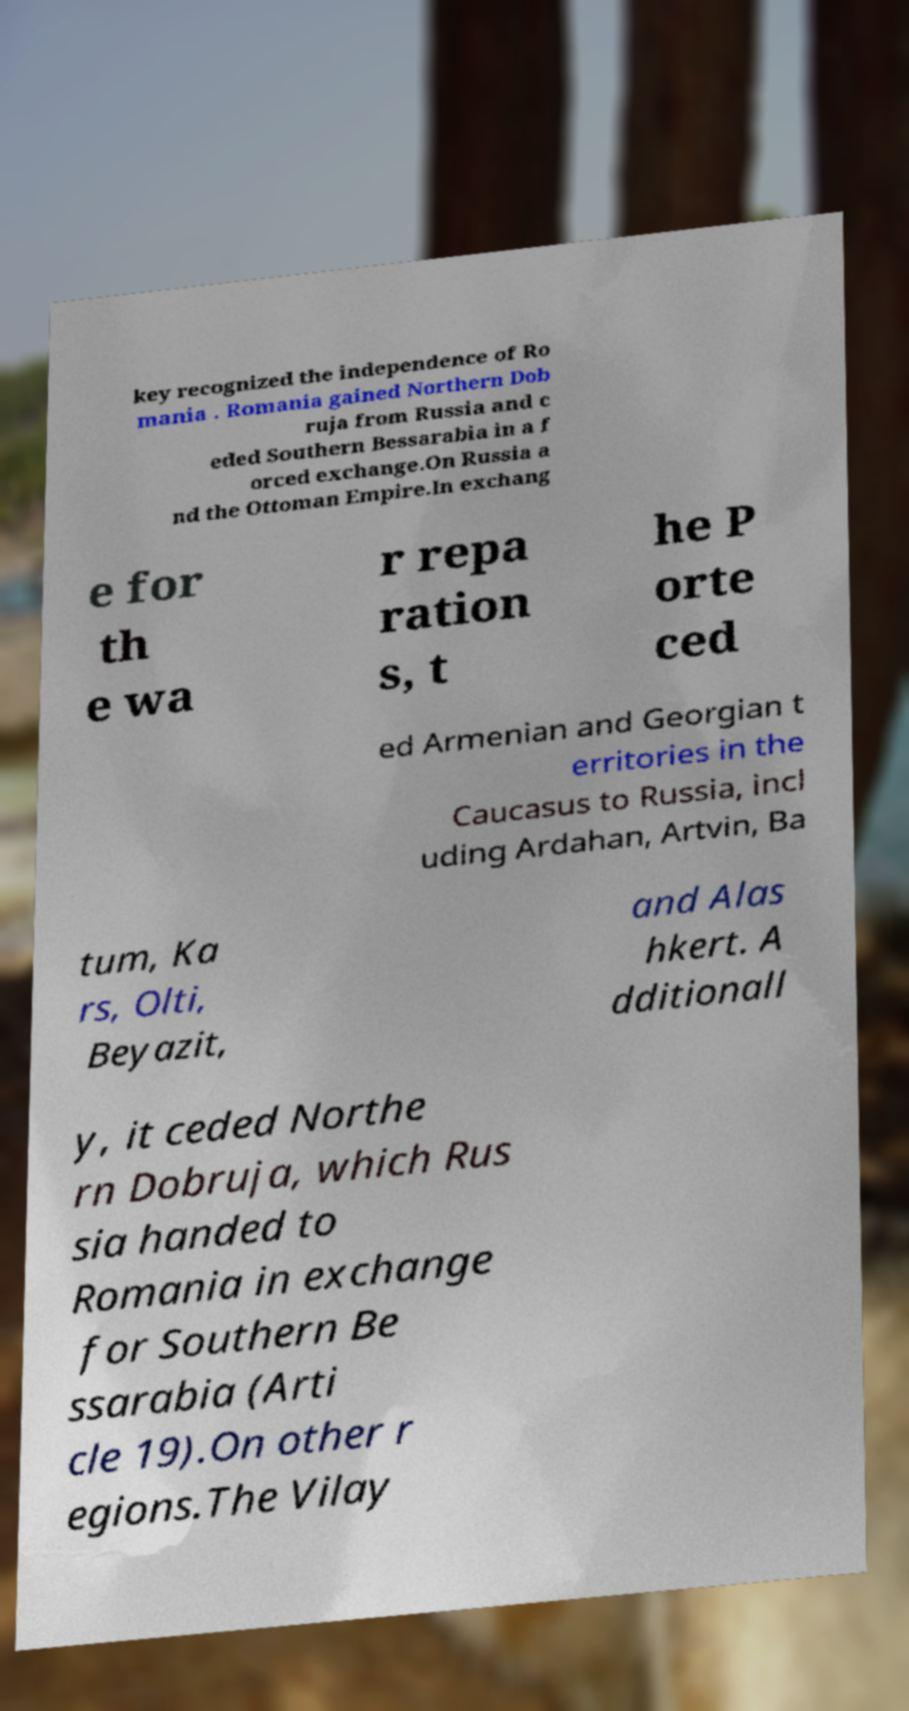Could you assist in decoding the text presented in this image and type it out clearly? key recognized the independence of Ro mania . Romania gained Northern Dob ruja from Russia and c eded Southern Bessarabia in a f orced exchange.On Russia a nd the Ottoman Empire.In exchang e for th e wa r repa ration s, t he P orte ced ed Armenian and Georgian t erritories in the Caucasus to Russia, incl uding Ardahan, Artvin, Ba tum, Ka rs, Olti, Beyazit, and Alas hkert. A dditionall y, it ceded Northe rn Dobruja, which Rus sia handed to Romania in exchange for Southern Be ssarabia (Arti cle 19).On other r egions.The Vilay 